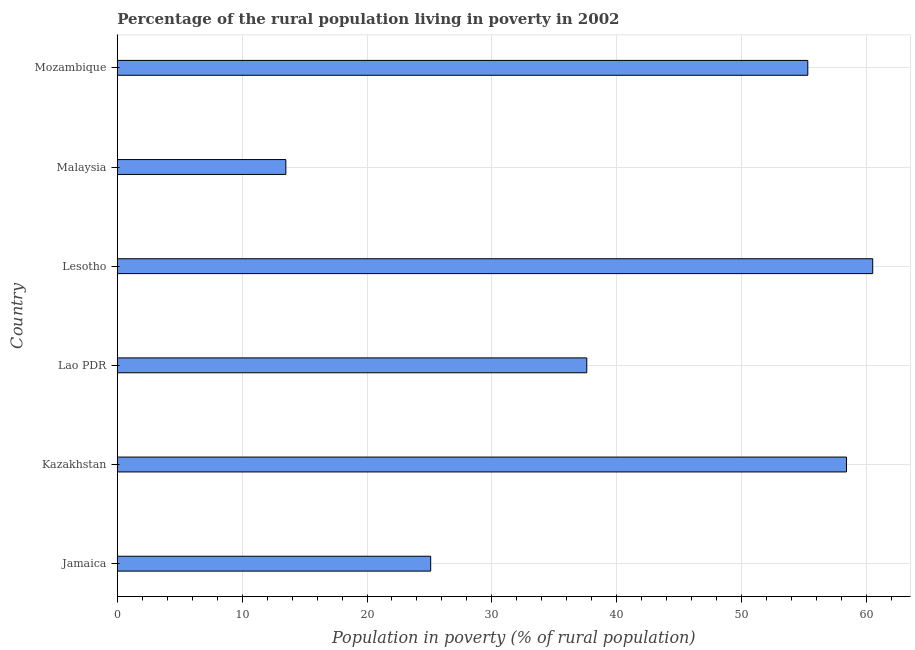What is the title of the graph?
Your answer should be very brief. Percentage of the rural population living in poverty in 2002. What is the label or title of the X-axis?
Give a very brief answer. Population in poverty (% of rural population). What is the label or title of the Y-axis?
Offer a very short reply. Country. What is the percentage of rural population living below poverty line in Jamaica?
Give a very brief answer. 25.1. Across all countries, what is the maximum percentage of rural population living below poverty line?
Keep it short and to the point. 60.5. Across all countries, what is the minimum percentage of rural population living below poverty line?
Provide a short and direct response. 13.5. In which country was the percentage of rural population living below poverty line maximum?
Your answer should be compact. Lesotho. In which country was the percentage of rural population living below poverty line minimum?
Ensure brevity in your answer.  Malaysia. What is the sum of the percentage of rural population living below poverty line?
Your answer should be compact. 250.4. What is the difference between the percentage of rural population living below poverty line in Lesotho and Mozambique?
Provide a succinct answer. 5.2. What is the average percentage of rural population living below poverty line per country?
Provide a succinct answer. 41.73. What is the median percentage of rural population living below poverty line?
Keep it short and to the point. 46.45. In how many countries, is the percentage of rural population living below poverty line greater than 50 %?
Make the answer very short. 3. What is the ratio of the percentage of rural population living below poverty line in Jamaica to that in Lesotho?
Provide a succinct answer. 0.41. Is the percentage of rural population living below poverty line in Lao PDR less than that in Lesotho?
Provide a short and direct response. Yes. Is the difference between the percentage of rural population living below poverty line in Kazakhstan and Lesotho greater than the difference between any two countries?
Give a very brief answer. No. What is the difference between the highest and the second highest percentage of rural population living below poverty line?
Make the answer very short. 2.1. Are all the bars in the graph horizontal?
Provide a succinct answer. Yes. How many countries are there in the graph?
Make the answer very short. 6. What is the Population in poverty (% of rural population) of Jamaica?
Your answer should be compact. 25.1. What is the Population in poverty (% of rural population) in Kazakhstan?
Your answer should be compact. 58.4. What is the Population in poverty (% of rural population) in Lao PDR?
Your answer should be very brief. 37.6. What is the Population in poverty (% of rural population) in Lesotho?
Offer a terse response. 60.5. What is the Population in poverty (% of rural population) in Malaysia?
Give a very brief answer. 13.5. What is the Population in poverty (% of rural population) of Mozambique?
Your response must be concise. 55.3. What is the difference between the Population in poverty (% of rural population) in Jamaica and Kazakhstan?
Offer a terse response. -33.3. What is the difference between the Population in poverty (% of rural population) in Jamaica and Lao PDR?
Provide a short and direct response. -12.5. What is the difference between the Population in poverty (% of rural population) in Jamaica and Lesotho?
Provide a short and direct response. -35.4. What is the difference between the Population in poverty (% of rural population) in Jamaica and Mozambique?
Your answer should be compact. -30.2. What is the difference between the Population in poverty (% of rural population) in Kazakhstan and Lao PDR?
Make the answer very short. 20.8. What is the difference between the Population in poverty (% of rural population) in Kazakhstan and Lesotho?
Your answer should be compact. -2.1. What is the difference between the Population in poverty (% of rural population) in Kazakhstan and Malaysia?
Keep it short and to the point. 44.9. What is the difference between the Population in poverty (% of rural population) in Kazakhstan and Mozambique?
Ensure brevity in your answer.  3.1. What is the difference between the Population in poverty (% of rural population) in Lao PDR and Lesotho?
Keep it short and to the point. -22.9. What is the difference between the Population in poverty (% of rural population) in Lao PDR and Malaysia?
Offer a terse response. 24.1. What is the difference between the Population in poverty (% of rural population) in Lao PDR and Mozambique?
Offer a very short reply. -17.7. What is the difference between the Population in poverty (% of rural population) in Lesotho and Mozambique?
Your answer should be very brief. 5.2. What is the difference between the Population in poverty (% of rural population) in Malaysia and Mozambique?
Offer a very short reply. -41.8. What is the ratio of the Population in poverty (% of rural population) in Jamaica to that in Kazakhstan?
Offer a terse response. 0.43. What is the ratio of the Population in poverty (% of rural population) in Jamaica to that in Lao PDR?
Provide a short and direct response. 0.67. What is the ratio of the Population in poverty (% of rural population) in Jamaica to that in Lesotho?
Give a very brief answer. 0.41. What is the ratio of the Population in poverty (% of rural population) in Jamaica to that in Malaysia?
Your answer should be very brief. 1.86. What is the ratio of the Population in poverty (% of rural population) in Jamaica to that in Mozambique?
Your answer should be compact. 0.45. What is the ratio of the Population in poverty (% of rural population) in Kazakhstan to that in Lao PDR?
Your answer should be very brief. 1.55. What is the ratio of the Population in poverty (% of rural population) in Kazakhstan to that in Lesotho?
Your answer should be compact. 0.96. What is the ratio of the Population in poverty (% of rural population) in Kazakhstan to that in Malaysia?
Offer a very short reply. 4.33. What is the ratio of the Population in poverty (% of rural population) in Kazakhstan to that in Mozambique?
Offer a terse response. 1.06. What is the ratio of the Population in poverty (% of rural population) in Lao PDR to that in Lesotho?
Keep it short and to the point. 0.62. What is the ratio of the Population in poverty (% of rural population) in Lao PDR to that in Malaysia?
Offer a terse response. 2.79. What is the ratio of the Population in poverty (% of rural population) in Lao PDR to that in Mozambique?
Give a very brief answer. 0.68. What is the ratio of the Population in poverty (% of rural population) in Lesotho to that in Malaysia?
Provide a succinct answer. 4.48. What is the ratio of the Population in poverty (% of rural population) in Lesotho to that in Mozambique?
Keep it short and to the point. 1.09. What is the ratio of the Population in poverty (% of rural population) in Malaysia to that in Mozambique?
Your answer should be compact. 0.24. 